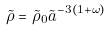Convert formula to latex. <formula><loc_0><loc_0><loc_500><loc_500>\tilde { \rho } = \tilde { \rho } _ { 0 } \tilde { a } ^ { - 3 ( 1 + \omega ) }</formula> 